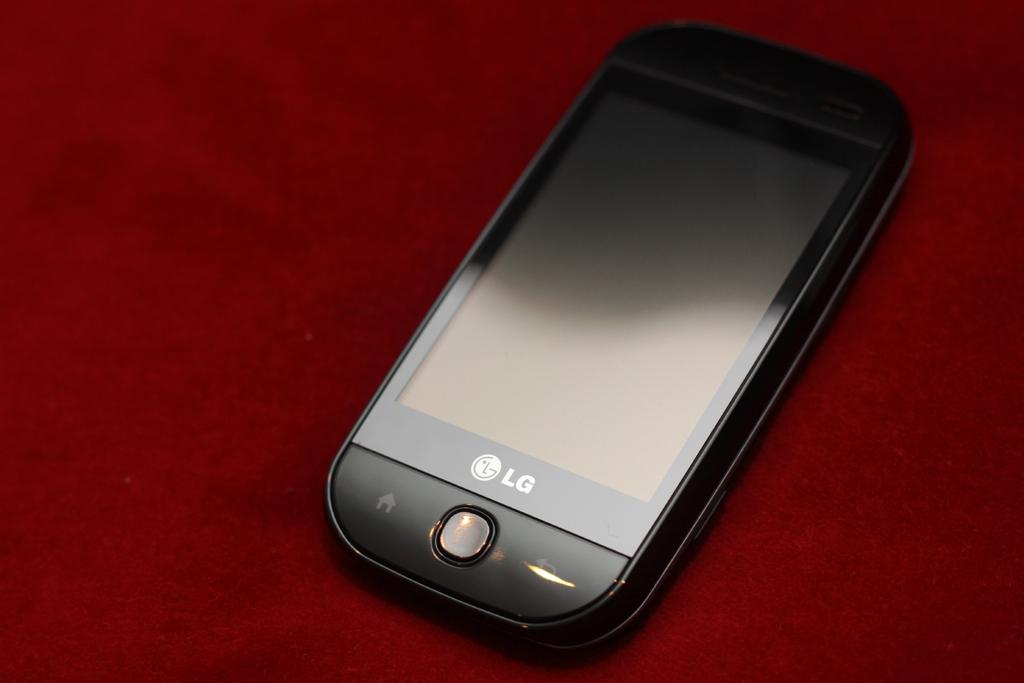Who manufactured the cell phone?
Offer a terse response. Lg. Is this a good cell phone manufacturer?
Keep it short and to the point. Unanswerable. 